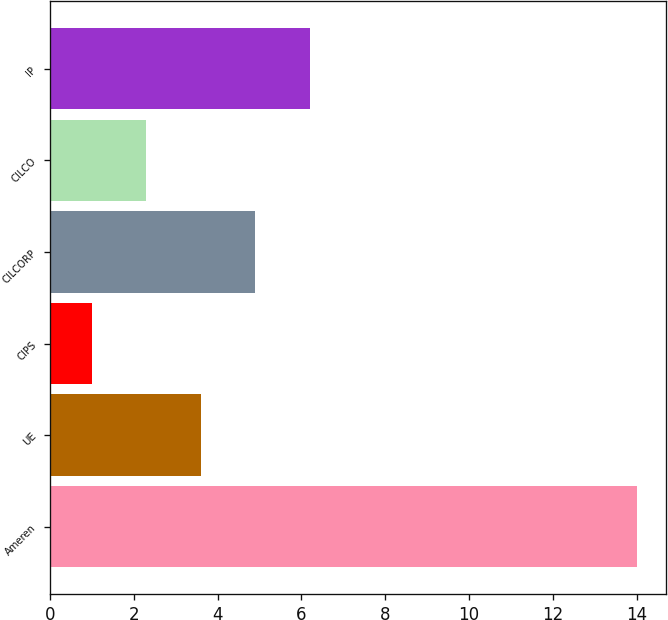Convert chart to OTSL. <chart><loc_0><loc_0><loc_500><loc_500><bar_chart><fcel>Ameren<fcel>UE<fcel>CIPS<fcel>CILCORP<fcel>CILCO<fcel>IP<nl><fcel>14<fcel>3.6<fcel>1<fcel>4.9<fcel>2.3<fcel>6.2<nl></chart> 